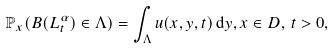<formula> <loc_0><loc_0><loc_500><loc_500>\mathbb { P } _ { x } ( B ( L ^ { \alpha } _ { t } ) \in \Lambda ) = \int _ { \Lambda } u ( x , y , t ) \, \mathrm d y , x \in D , \, t > 0 ,</formula> 